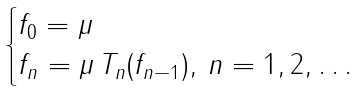Convert formula to latex. <formula><loc_0><loc_0><loc_500><loc_500>\begin{cases} f _ { 0 } = \mu \\ f _ { n } = \mu \, T _ { n } ( f _ { n - 1 } ) , \, n = 1 , 2 , \dots \end{cases}</formula> 